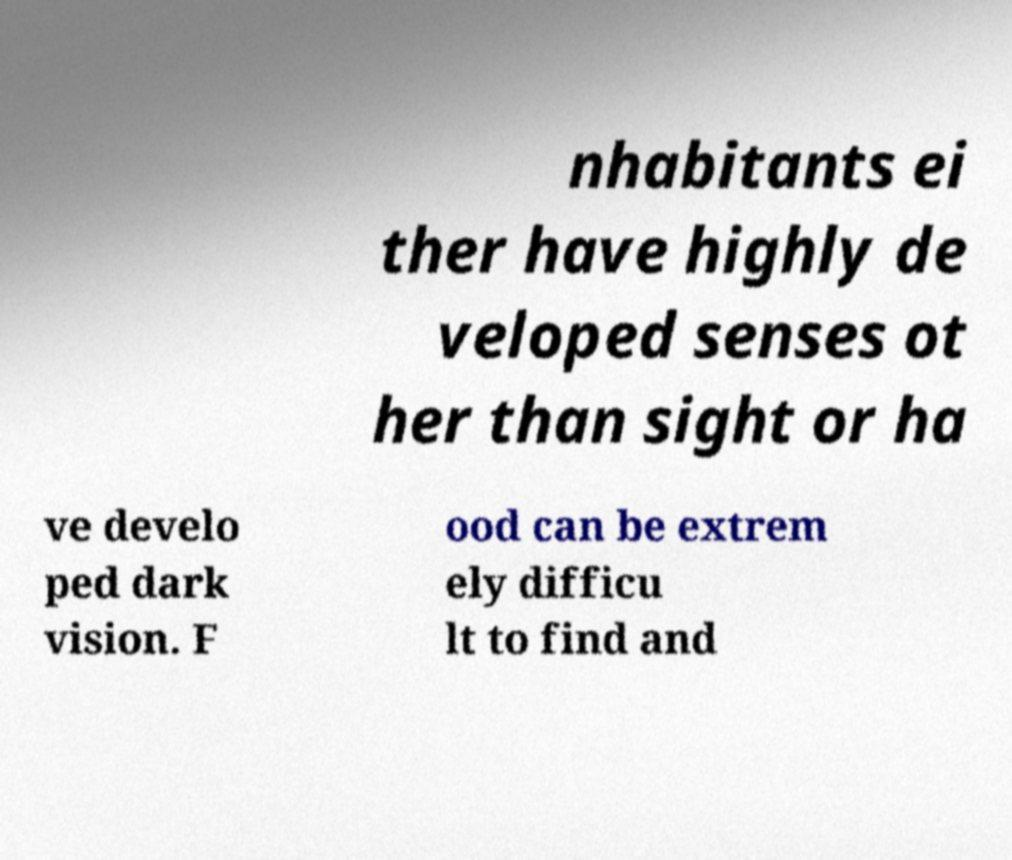Could you assist in decoding the text presented in this image and type it out clearly? nhabitants ei ther have highly de veloped senses ot her than sight or ha ve develo ped dark vision. F ood can be extrem ely difficu lt to find and 